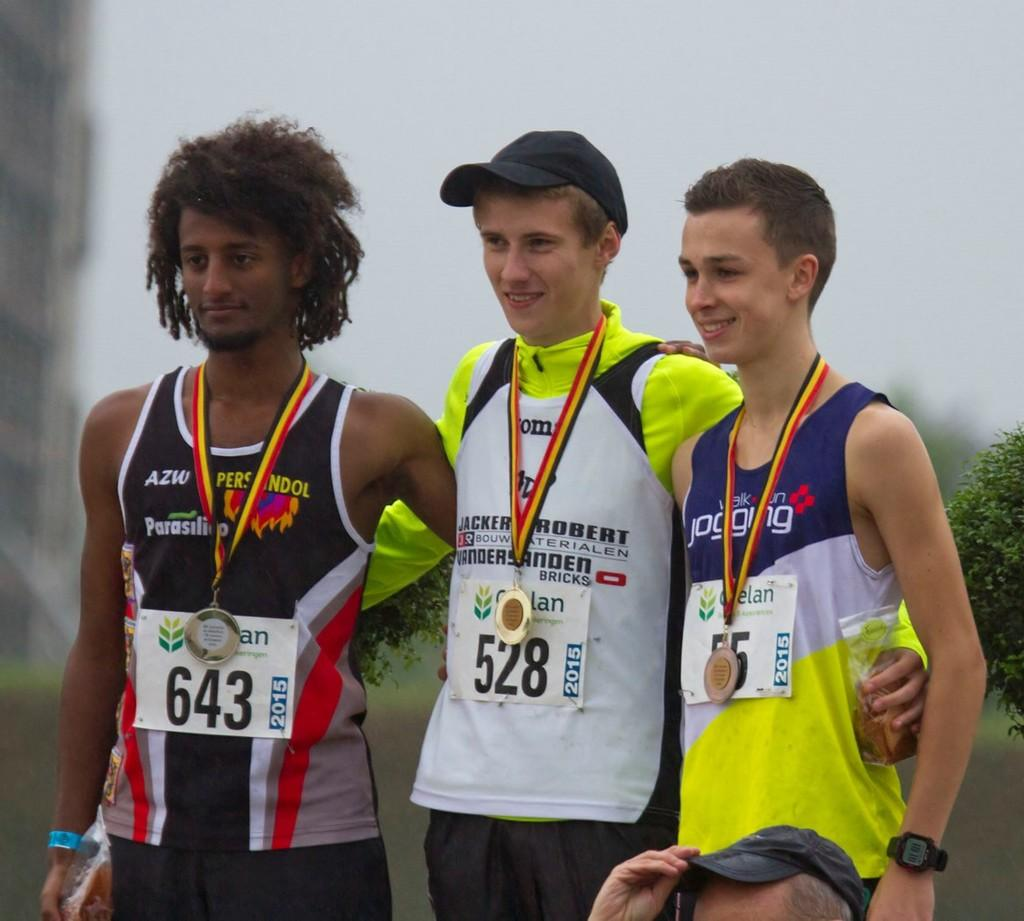<image>
Create a compact narrative representing the image presented. The 3 medalists are posing for a photo and the gold went to no. 528. 